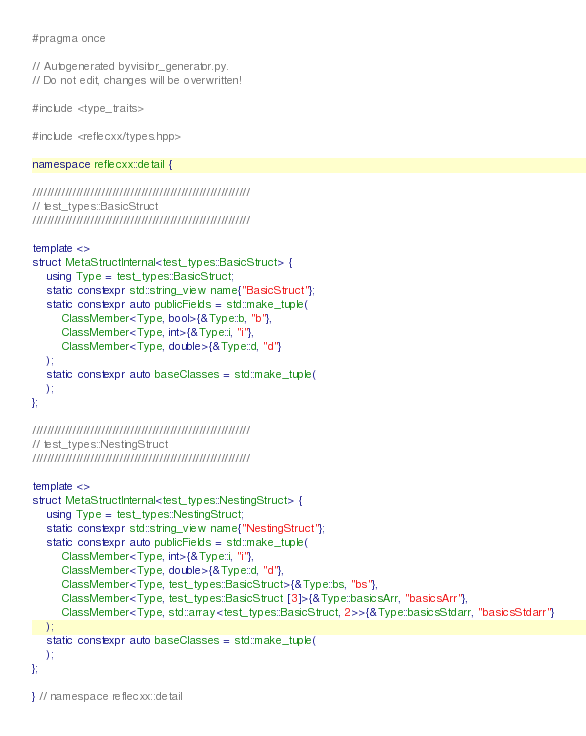Convert code to text. <code><loc_0><loc_0><loc_500><loc_500><_C++_>#pragma once

// Autogenerated byvisitor_generator.py.
// Do not edit, changes will be overwritten!

#include <type_traits>

#include <reflecxx/types.hpp>

namespace reflecxx::detail {

////////////////////////////////////////////////////////////
// test_types::BasicStruct
////////////////////////////////////////////////////////////

template <>
struct MetaStructInternal<test_types::BasicStruct> {
    using Type = test_types::BasicStruct;
    static constexpr std::string_view name{"BasicStruct"};
    static constexpr auto publicFields = std::make_tuple(
        ClassMember<Type, bool>{&Type::b, "b"},
        ClassMember<Type, int>{&Type::i, "i"},
        ClassMember<Type, double>{&Type::d, "d"}
    );
    static constexpr auto baseClasses = std::make_tuple(
    );
};

////////////////////////////////////////////////////////////
// test_types::NestingStruct
////////////////////////////////////////////////////////////

template <>
struct MetaStructInternal<test_types::NestingStruct> {
    using Type = test_types::NestingStruct;
    static constexpr std::string_view name{"NestingStruct"};
    static constexpr auto publicFields = std::make_tuple(
        ClassMember<Type, int>{&Type::i, "i"},
        ClassMember<Type, double>{&Type::d, "d"},
        ClassMember<Type, test_types::BasicStruct>{&Type::bs, "bs"},
        ClassMember<Type, test_types::BasicStruct [3]>{&Type::basicsArr, "basicsArr"},
        ClassMember<Type, std::array<test_types::BasicStruct, 2>>{&Type::basicsStdarr, "basicsStdarr"}
    );
    static constexpr auto baseClasses = std::make_tuple(
    );
};

} // namespace reflecxx::detail
</code> 